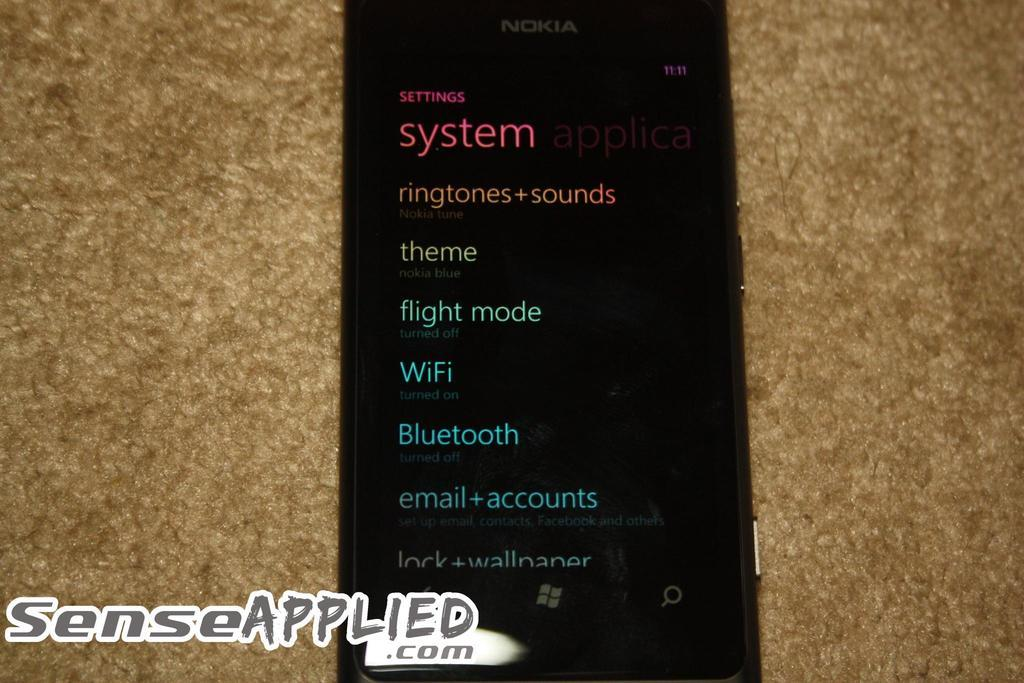<image>
Provide a brief description of the given image. A Nokia cellphone showing the Settings screen where one can change ringtones. 